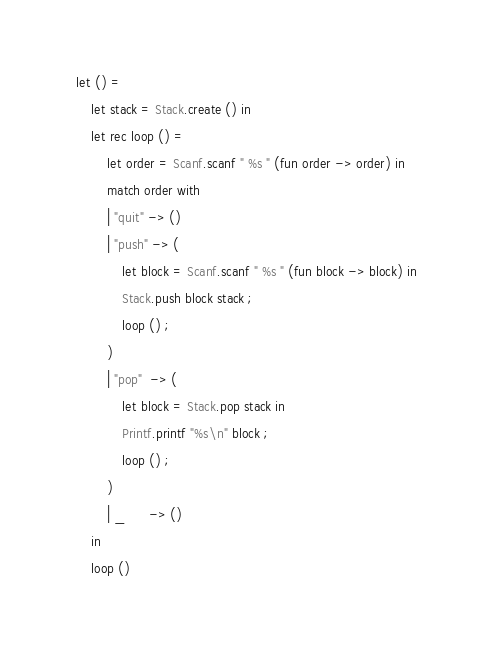Convert code to text. <code><loc_0><loc_0><loc_500><loc_500><_OCaml_>let () =
    let stack = Stack.create () in
    let rec loop () =
        let order = Scanf.scanf " %s " (fun order -> order) in
        match order with
        | "quit" -> ()
        | "push" -> (
            let block = Scanf.scanf " %s " (fun block -> block) in
            Stack.push block stack ;
            loop () ;
        )
        | "pop"  -> (
            let block = Stack.pop stack in
            Printf.printf "%s\n" block ;
            loop () ;
        )
        | _      -> ()
    in
    loop ()</code> 